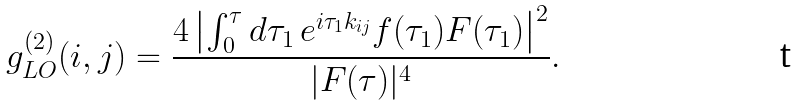Convert formula to latex. <formula><loc_0><loc_0><loc_500><loc_500>g ^ { ( 2 ) } _ { L O } ( i , j ) & = \frac { 4 \left | \int _ { 0 } ^ { \tau } d \tau _ { 1 } \, e ^ { i \tau _ { 1 } k _ { i j } } f ( \tau _ { 1 } ) F ( \tau _ { 1 } ) \right | ^ { 2 } } { | F ( \tau ) | ^ { 4 } } .</formula> 